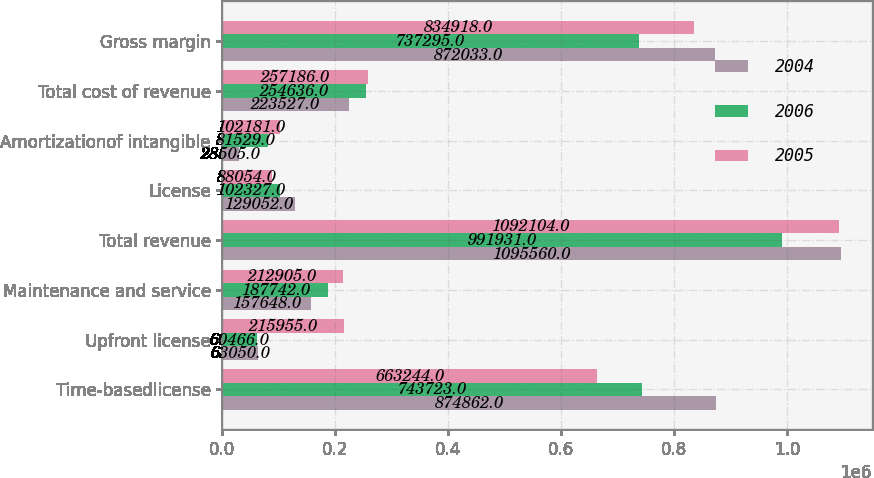Convert chart. <chart><loc_0><loc_0><loc_500><loc_500><stacked_bar_chart><ecel><fcel>Time-basedlicense<fcel>Upfront license<fcel>Maintenance and service<fcel>Total revenue<fcel>License<fcel>Amortizationof intangible<fcel>Total cost of revenue<fcel>Gross margin<nl><fcel>2004<fcel>874862<fcel>63050<fcel>157648<fcel>1.09556e+06<fcel>129052<fcel>28505<fcel>223527<fcel>872033<nl><fcel>2006<fcel>743723<fcel>60466<fcel>187742<fcel>991931<fcel>102327<fcel>81529<fcel>254636<fcel>737295<nl><fcel>2005<fcel>663244<fcel>215955<fcel>212905<fcel>1.0921e+06<fcel>88054<fcel>102181<fcel>257186<fcel>834918<nl></chart> 